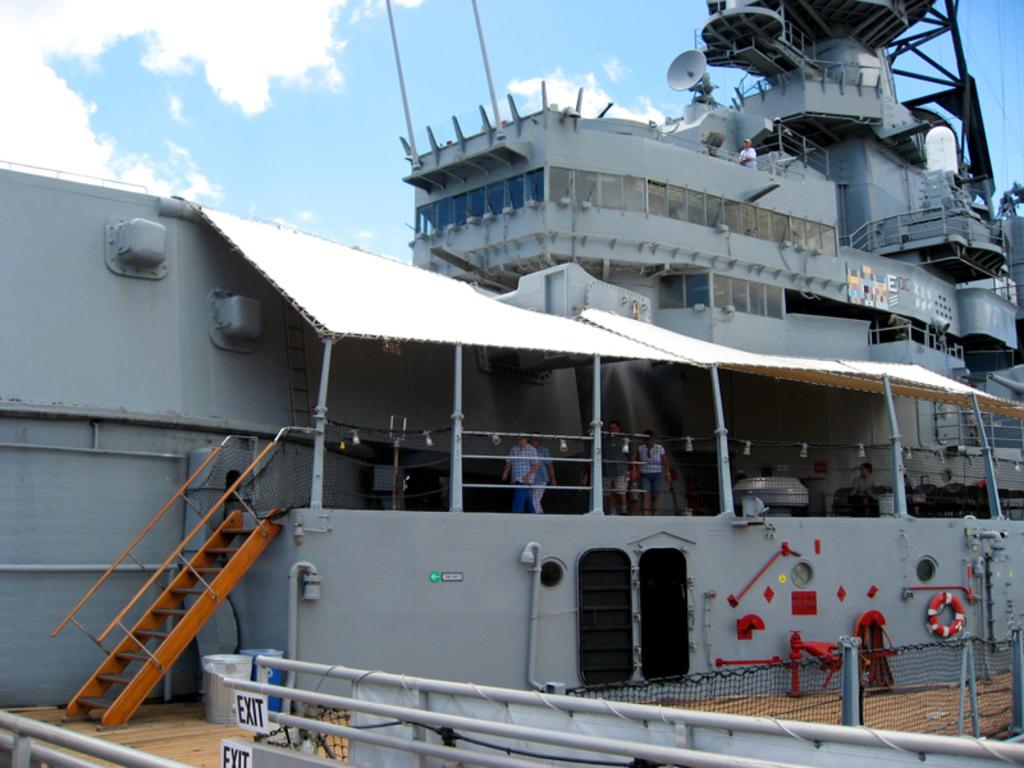What sign is shown in the picture?
Your answer should be very brief. Exit. 